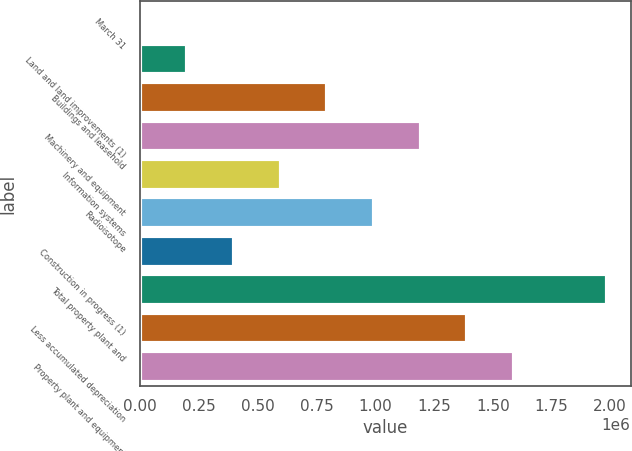Convert chart. <chart><loc_0><loc_0><loc_500><loc_500><bar_chart><fcel>March 31<fcel>Land and land improvements (1)<fcel>Buildings and leasehold<fcel>Machinery and equipment<fcel>Information systems<fcel>Radioisotope<fcel>Construction in progress (1)<fcel>Total property plant and<fcel>Less accumulated depreciation<fcel>Property plant and equipment<nl><fcel>2019<fcel>200549<fcel>796138<fcel>1.1932e+06<fcel>597608<fcel>994668<fcel>399079<fcel>1.98732e+06<fcel>1.39173e+06<fcel>1.59026e+06<nl></chart> 